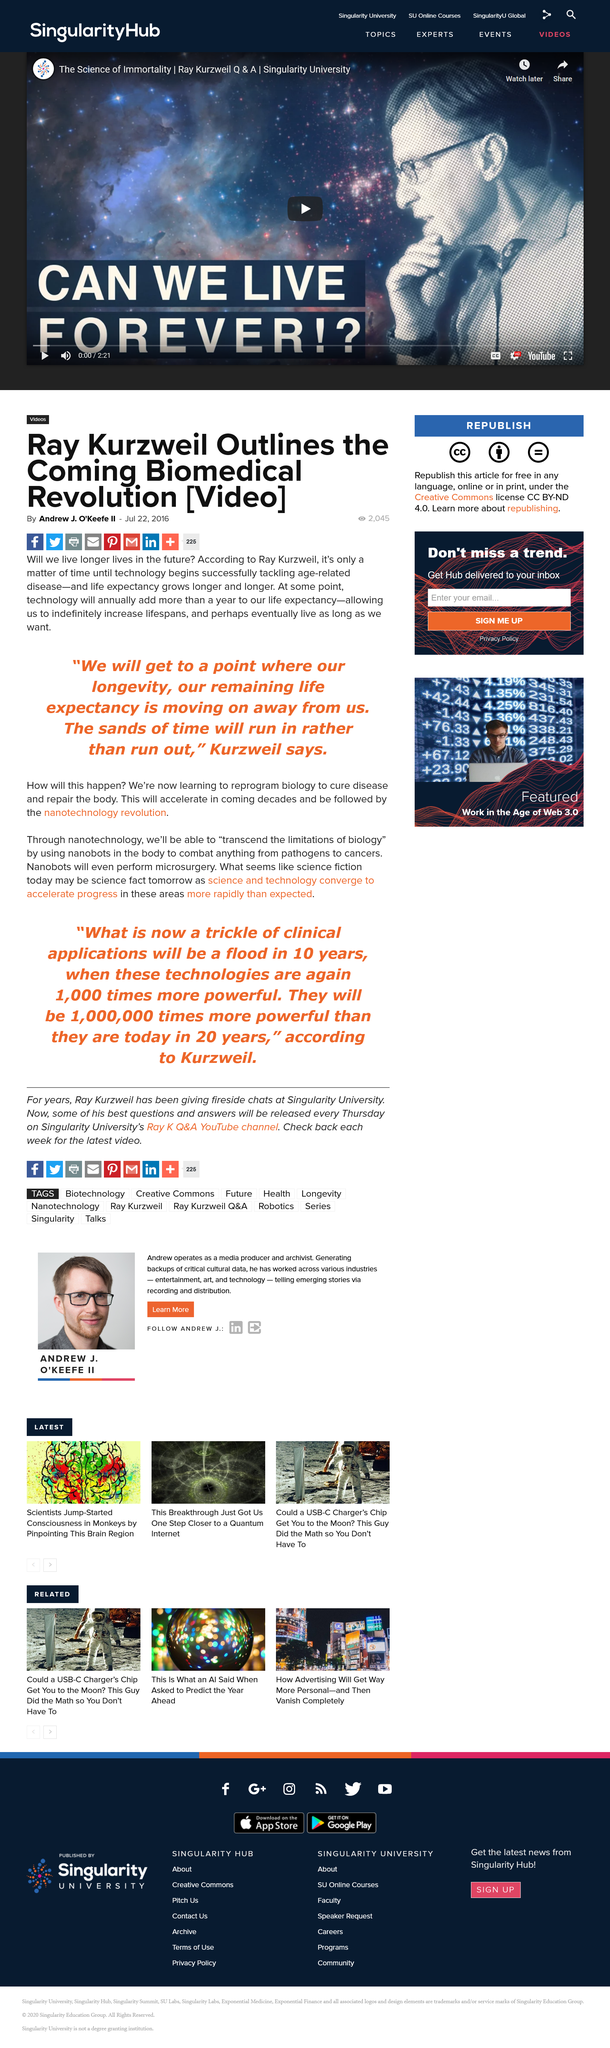Point out several critical features in this image. According to Ray Kurzweil, technology will be used to expand lifespans by reprogramming biology to cure diseases and repair the body, which will ultimately lead to increased lifespan. According to Ray Kurzweil, after we learn to reprogram biology to cure disease and repair the body in order to lengthen lifespans using technology, a phenomenon will occur that will be followed by the nanotechnology revolution, where biological systems will be reprogrammed to lengthen lifespans and repair the body, and new technologies will be developed to manipulate matter at the nanoscale. In the future, technology will allow people to live longer lives, as stated by Ray Kurzweil. 